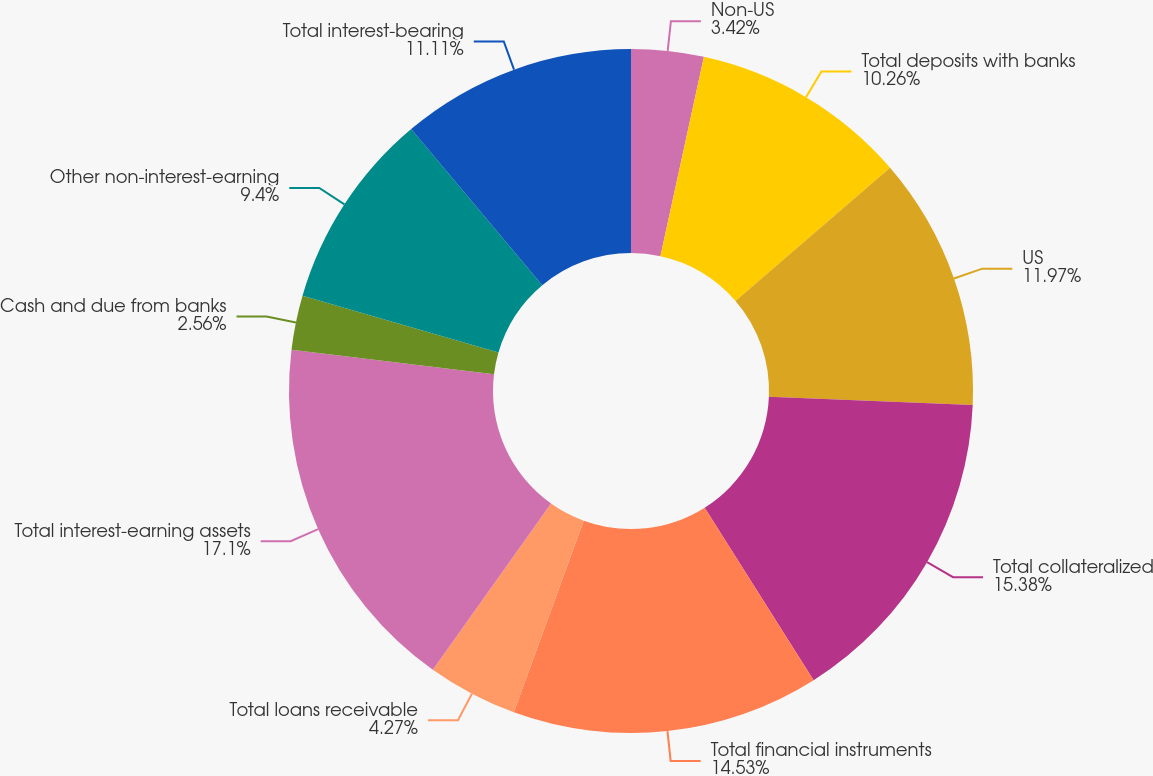Convert chart to OTSL. <chart><loc_0><loc_0><loc_500><loc_500><pie_chart><fcel>Non-US<fcel>Total deposits with banks<fcel>US<fcel>Total collateralized<fcel>Total financial instruments<fcel>Total loans receivable<fcel>Total interest-earning assets<fcel>Cash and due from banks<fcel>Other non-interest-earning<fcel>Total interest-bearing<nl><fcel>3.42%<fcel>10.26%<fcel>11.97%<fcel>15.38%<fcel>14.53%<fcel>4.27%<fcel>17.09%<fcel>2.56%<fcel>9.4%<fcel>11.11%<nl></chart> 